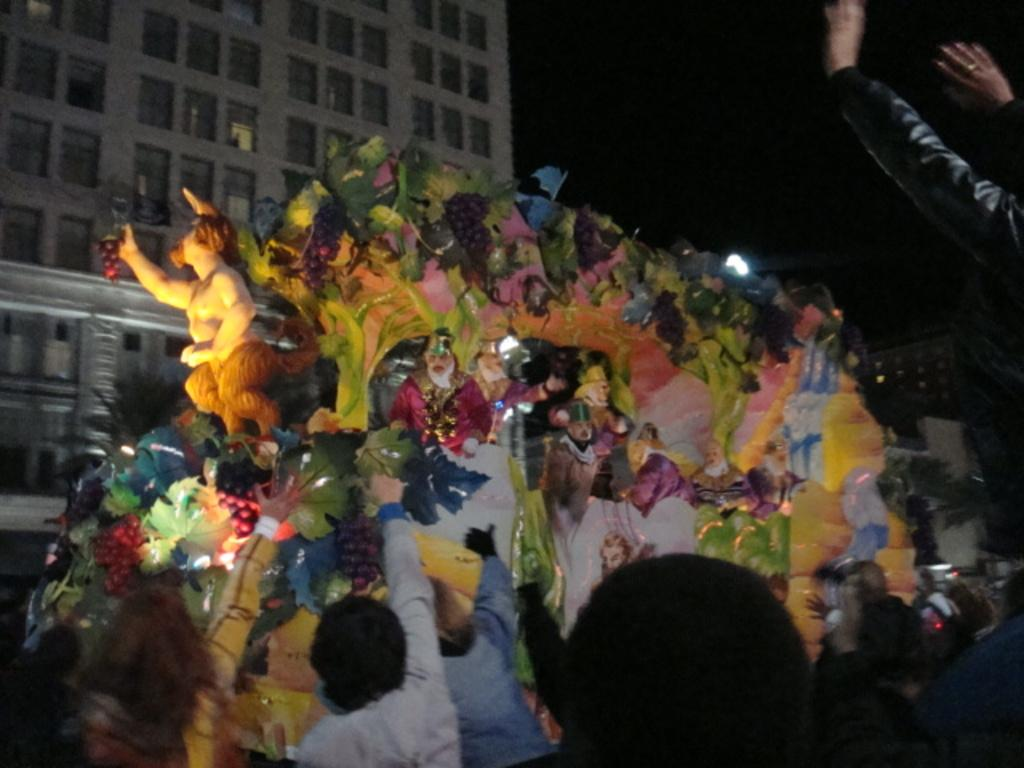Who or what can be seen in the image? There are people and sculptures in the image. What is on the vehicle in the image? There are decorative objects on a vehicle. What type of structure is visible in the image? There is a building in the image. What kind of illumination is present in the image? There is a light in the image. How would you describe the background of the image? The background of the image is dark. How many ladybugs can be seen on the sign in the image? There is no sign or ladybugs present in the image. What is the cent value of the currency depicted on the vehicle in the image? There is no currency or cent value mentioned in the image. 